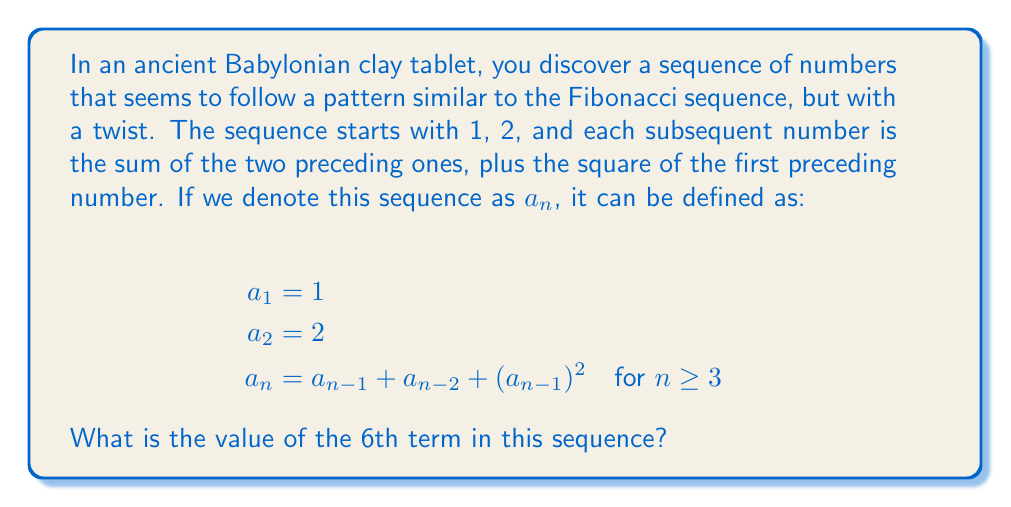Can you answer this question? Let's calculate the terms of this sequence step by step:

1) We're given $a_1 = 1$ and $a_2 = 2$

2) For $a_3$:
   $a_3 = a_2 + a_1 + (a_2)^2$
   $a_3 = 2 + 1 + 2^2 = 3 + 4 = 7$

3) For $a_4$:
   $a_4 = a_3 + a_2 + (a_3)^2$
   $a_4 = 7 + 2 + 7^2 = 9 + 49 = 58$

4) For $a_5$:
   $a_5 = a_4 + a_3 + (a_4)^2$
   $a_5 = 58 + 7 + 58^2 = 65 + 3364 = 3429$

5) Finally, for $a_6$:
   $a_6 = a_5 + a_4 + (a_5)^2$
   $a_6 = 3429 + 58 + 3429^2$
   $a_6 = 3487 + 11758041 = 11761528$

Therefore, the 6th term in the sequence is 11,761,528.

This sequence demonstrates how ancient civilizations might have explored variations on known sequences, potentially leading to new mathematical discoveries. It combines elements of the Fibonacci sequence with the concept of square numbers, both of which were known to ancient mathematicians.
Answer: 11,761,528 